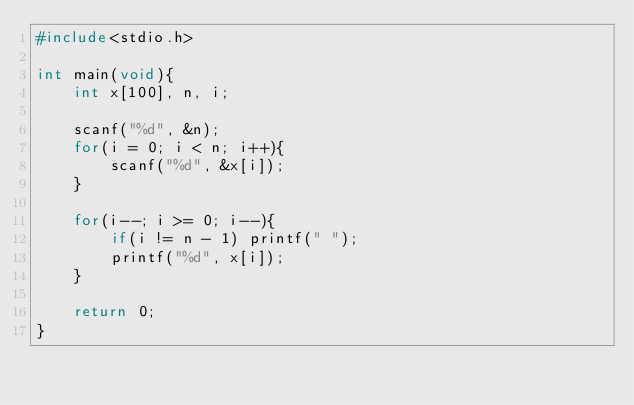<code> <loc_0><loc_0><loc_500><loc_500><_C_>#include<stdio.h>

int main(void){
    int x[100], n, i;

    scanf("%d", &n);
    for(i = 0; i < n; i++){
        scanf("%d", &x[i]);
    }

    for(i--; i >= 0; i--){
        if(i != n - 1) printf(" ");
        printf("%d", x[i]);
    }

    return 0;
}</code> 